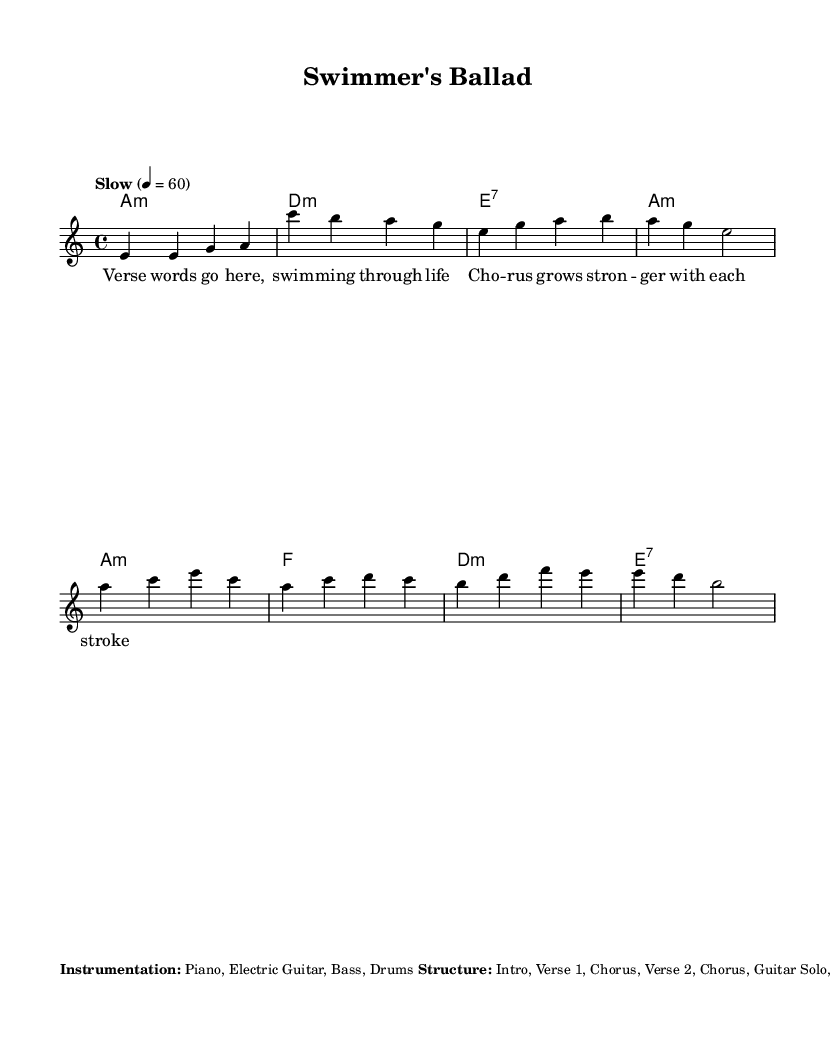What is the key signature of this music? The key signature is indicated at the beginning of the score with the letter 'a' and a minor label, which signifies that the piece is in A minor.
Answer: A minor What is the time signature of this composition? The time signature is shown after the key signature, represented by the fraction 4/4, indicating that there are four beats in each measure with a quarter note getting one beat.
Answer: 4/4 What is the tempo marking of this piece? The tempo is indicated with the word "Slow" and a metronome marking of 60, which suggests playing the piece slowly at 60 beats per minute.
Answer: Slow 60 How many sections does the structure of the piece include? The structure includes the following sections: Intro, Verse 1, Chorus, Verse 2, Chorus, Guitar Solo, Chorus, and Outro, totaling eight sections.
Answer: Eight What type of chords are predominantly used in the piece? The chord symbols are provided and indicate the use of minor and dominant seventh chords typical in blues, specifically A minor, D minor, and E7.
Answer: Minor and Dominant seventh What performance technique is suggested for the melody? The additional notes mention using blue notes in the melody, which are typically flattened 3rd, 5th, and 7th notes characteristic of the blues scale.
Answer: Blue notes What instrumentation is specified for the arrangement? The performance indications mention four instruments: Piano, Electric Guitar, Bass, and Drums, suggesting a classic blues band setup.
Answer: Piano, Electric Guitar, Bass, Drums 